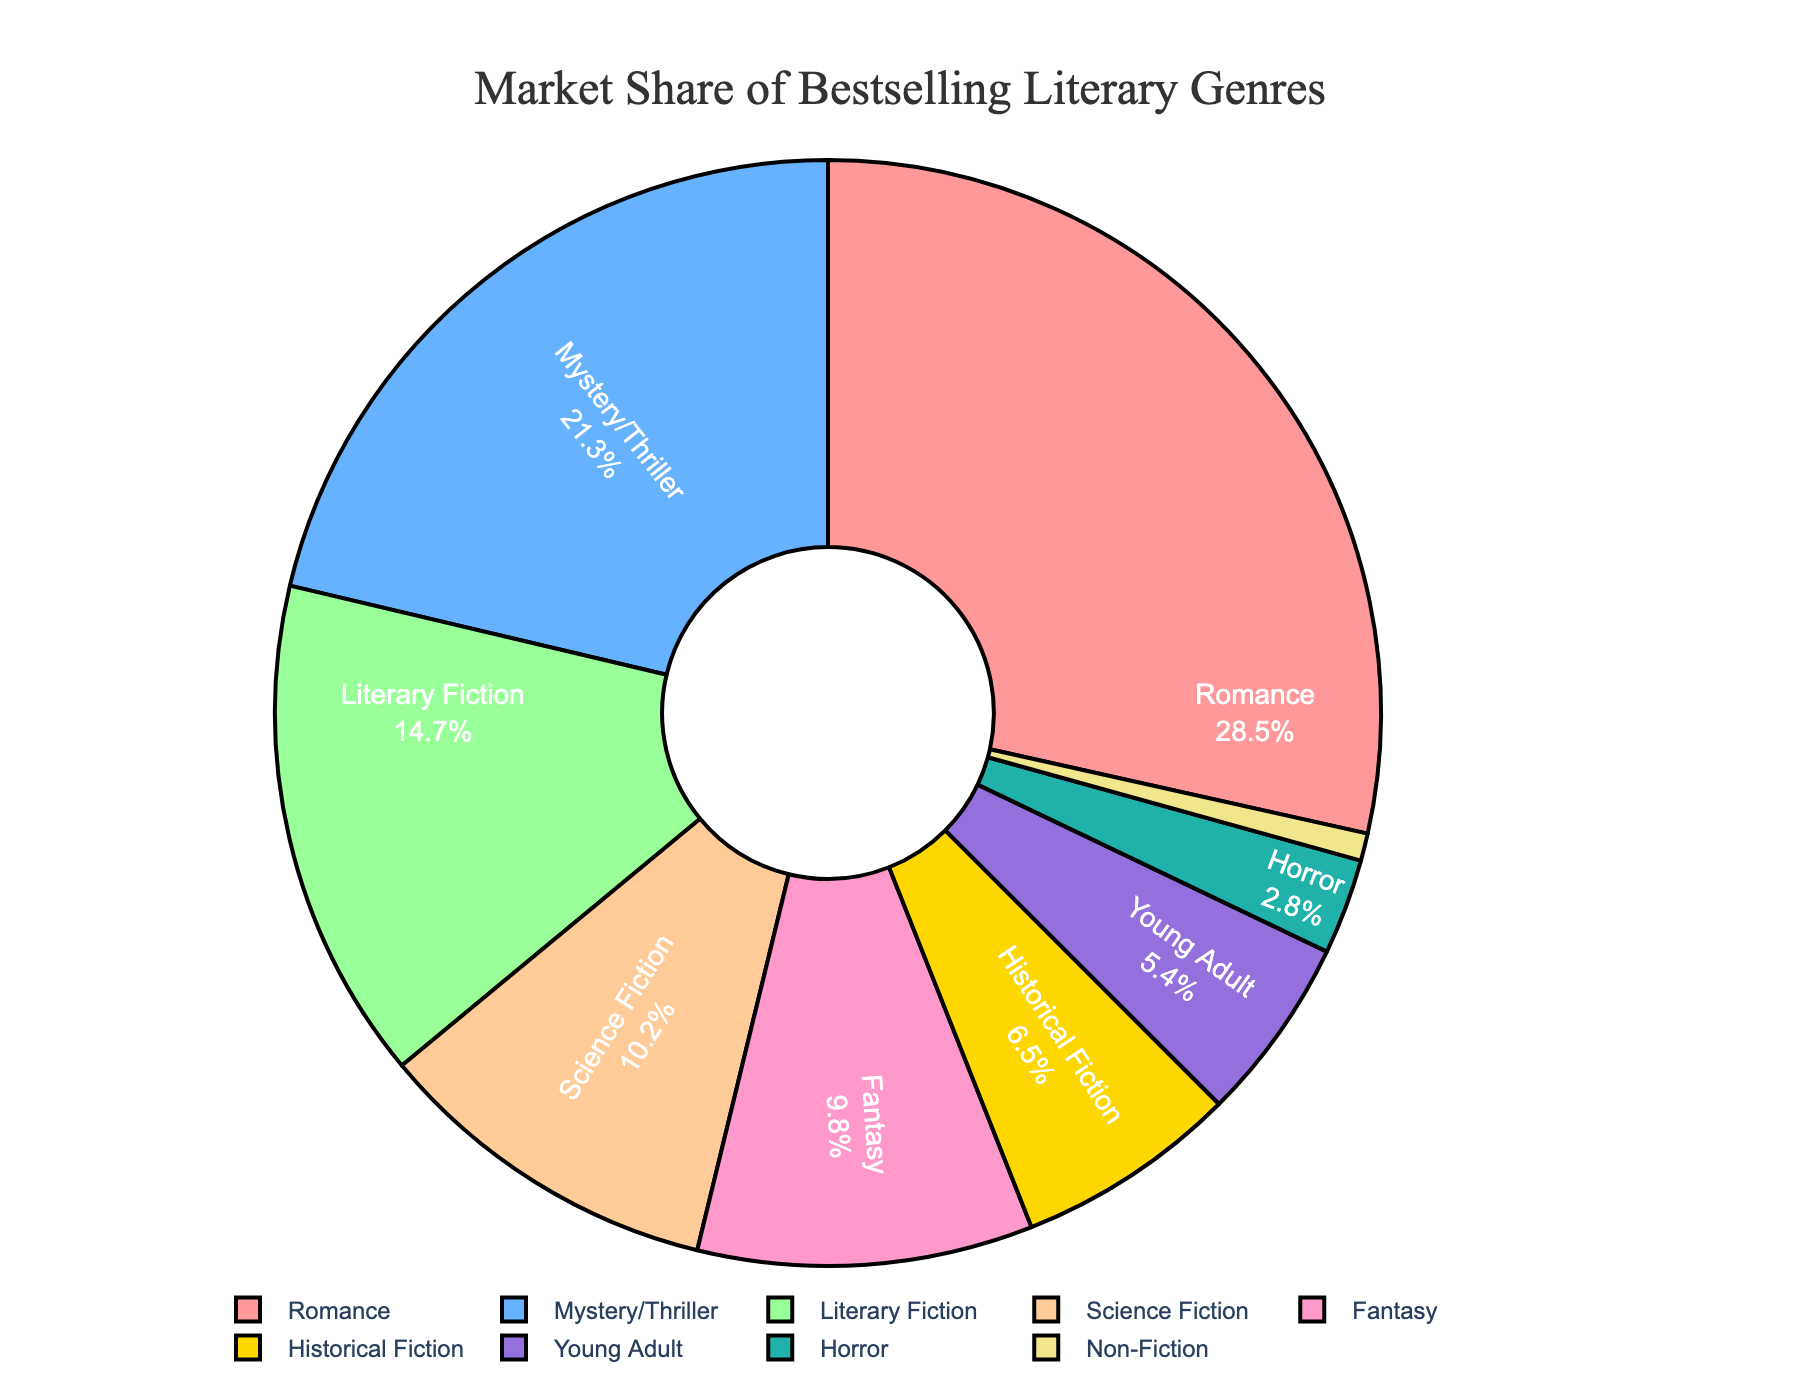What genre has the largest market share? To determine which genre has the largest market share, we look for the segment with the highest percentage. From the data, Romance has the highest market share with 28.5%.
Answer: Romance Which two genres have the closest market shares? By comparing the percentages, Fantasy (9.8%) and Science Fiction (10.2%) have the closest market shares, with a difference of only 0.4%.
Answer: Fantasy and Science Fiction What is the combined market share of Mystery/Thriller and Horror genres? Add the market shares of Mystery/Thriller (21.3%) and Horror (2.8%) genres. 21.3% + 2.8% = 24.1%
Answer: 24.1% Which genre's market share is just under 10%? We look for the segment just below 10%. Fantasy has a market share of 9.8%, which fits the requirement.
Answer: Fantasy How much more market share does Romance have compared to Literary Fiction? Subtract the market share of Literary Fiction (14.7%) from Romance (28.5%) to find the difference. 28.5% - 14.7% = 13.8%
Answer: 13.8% Which color is used to represent the Young Adult genre in the pie chart? By associating the given data to the corresponding segments and colors, Young Adult is represented by a shade of teal color.
Answer: Teal What is the average market share of Historical Fiction and Non-Fiction genres? Add the market shares of Historical Fiction (6.5%) and Non-Fiction (0.8%) and then divide by 2: (6.5% + 0.8%) / 2 = 3.65%
Answer: 3.65% Which genre has a smaller market share: Fantasy or Historical Fiction? Compare the market shares of Fantasy (9.8%) and Historical Fiction (6.5%). Historical Fiction has a smaller market share.
Answer: Historical Fiction 